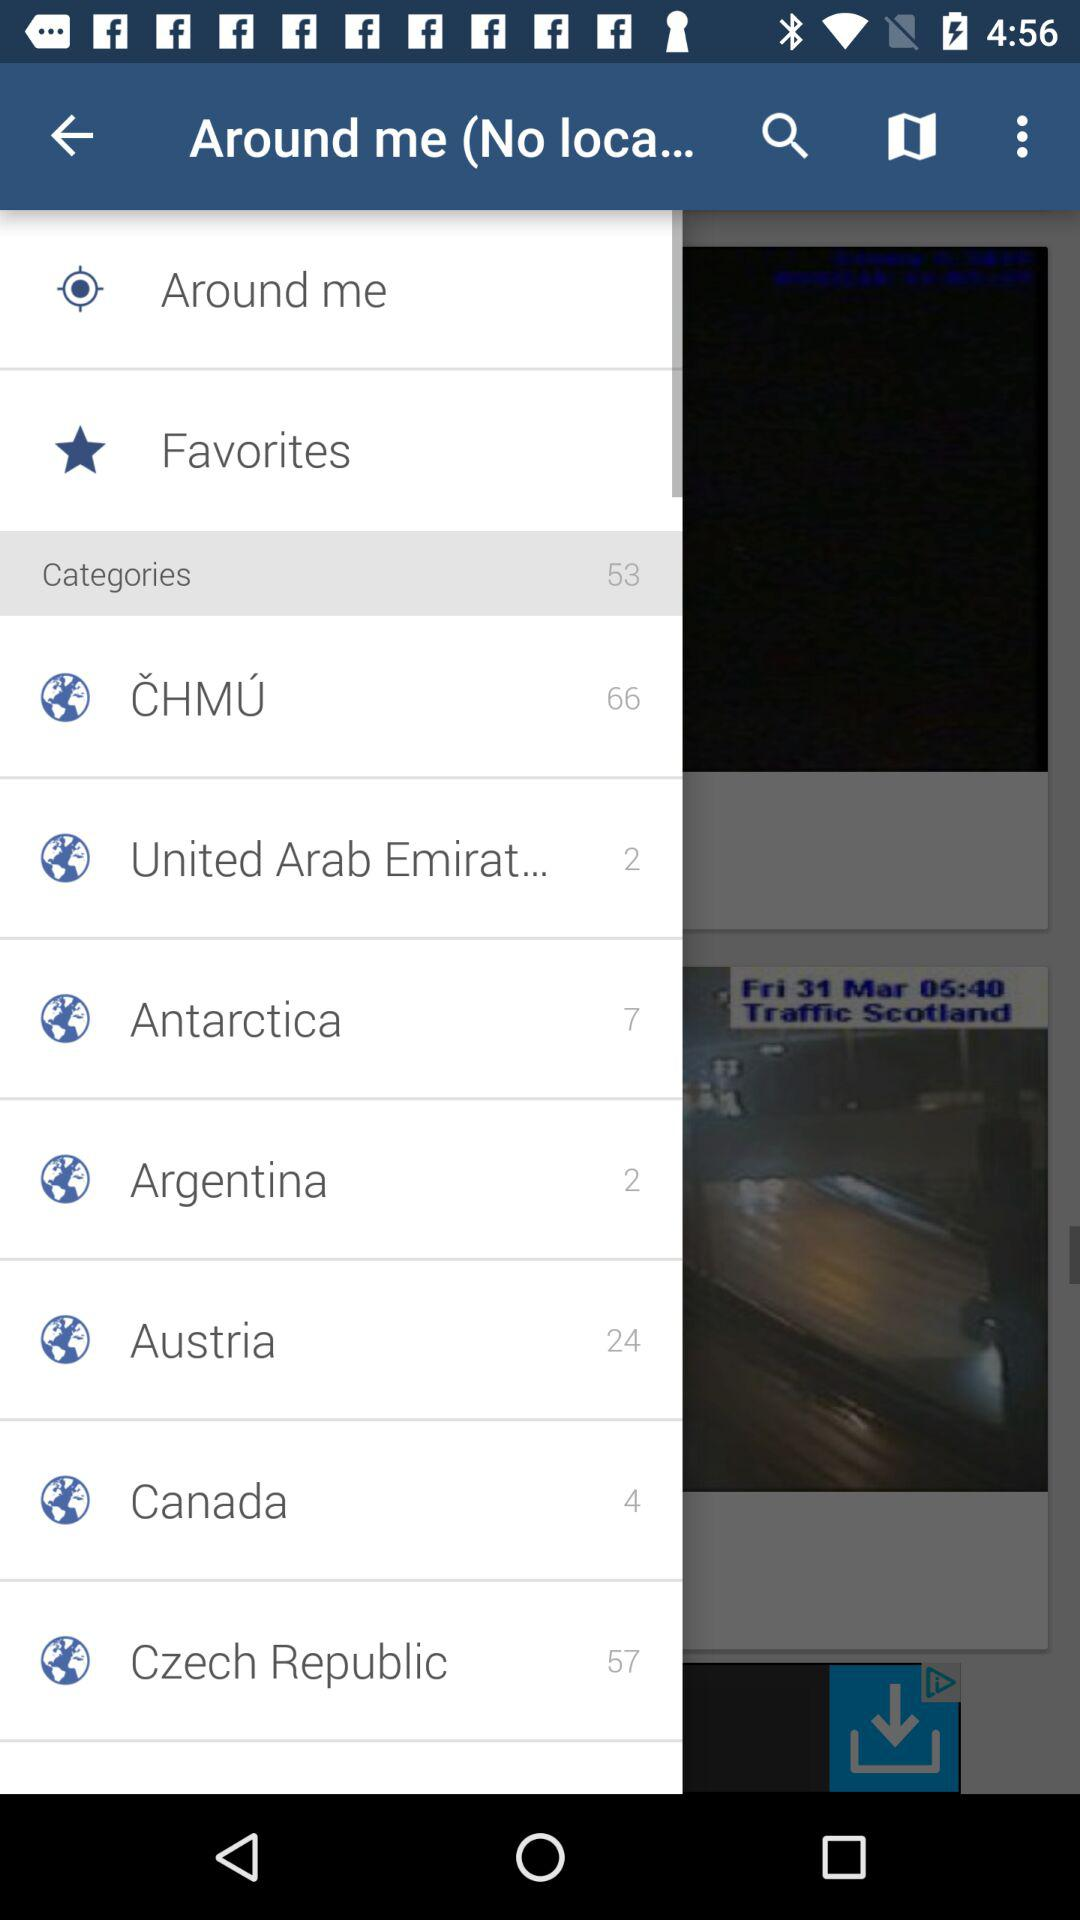How many categories are in CHMU? There are 66 categories in CHMU. 